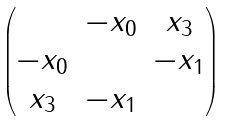<formula> <loc_0><loc_0><loc_500><loc_500>\begin{pmatrix} & - x _ { 0 } & x _ { 3 } \\ - x _ { 0 } & & - x _ { 1 } \\ x _ { 3 } & - x _ { 1 } & \end{pmatrix}</formula> 